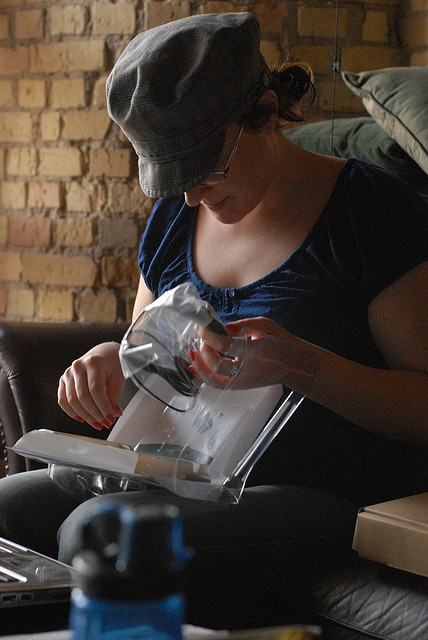Describe the objects in this image and their specific colors. I can see people in olive, black, gray, maroon, and darkgray tones, bottle in olive, black, navy, blue, and gray tones, couch in olive, black, gray, and maroon tones, and laptop in olive, gray, black, and white tones in this image. 